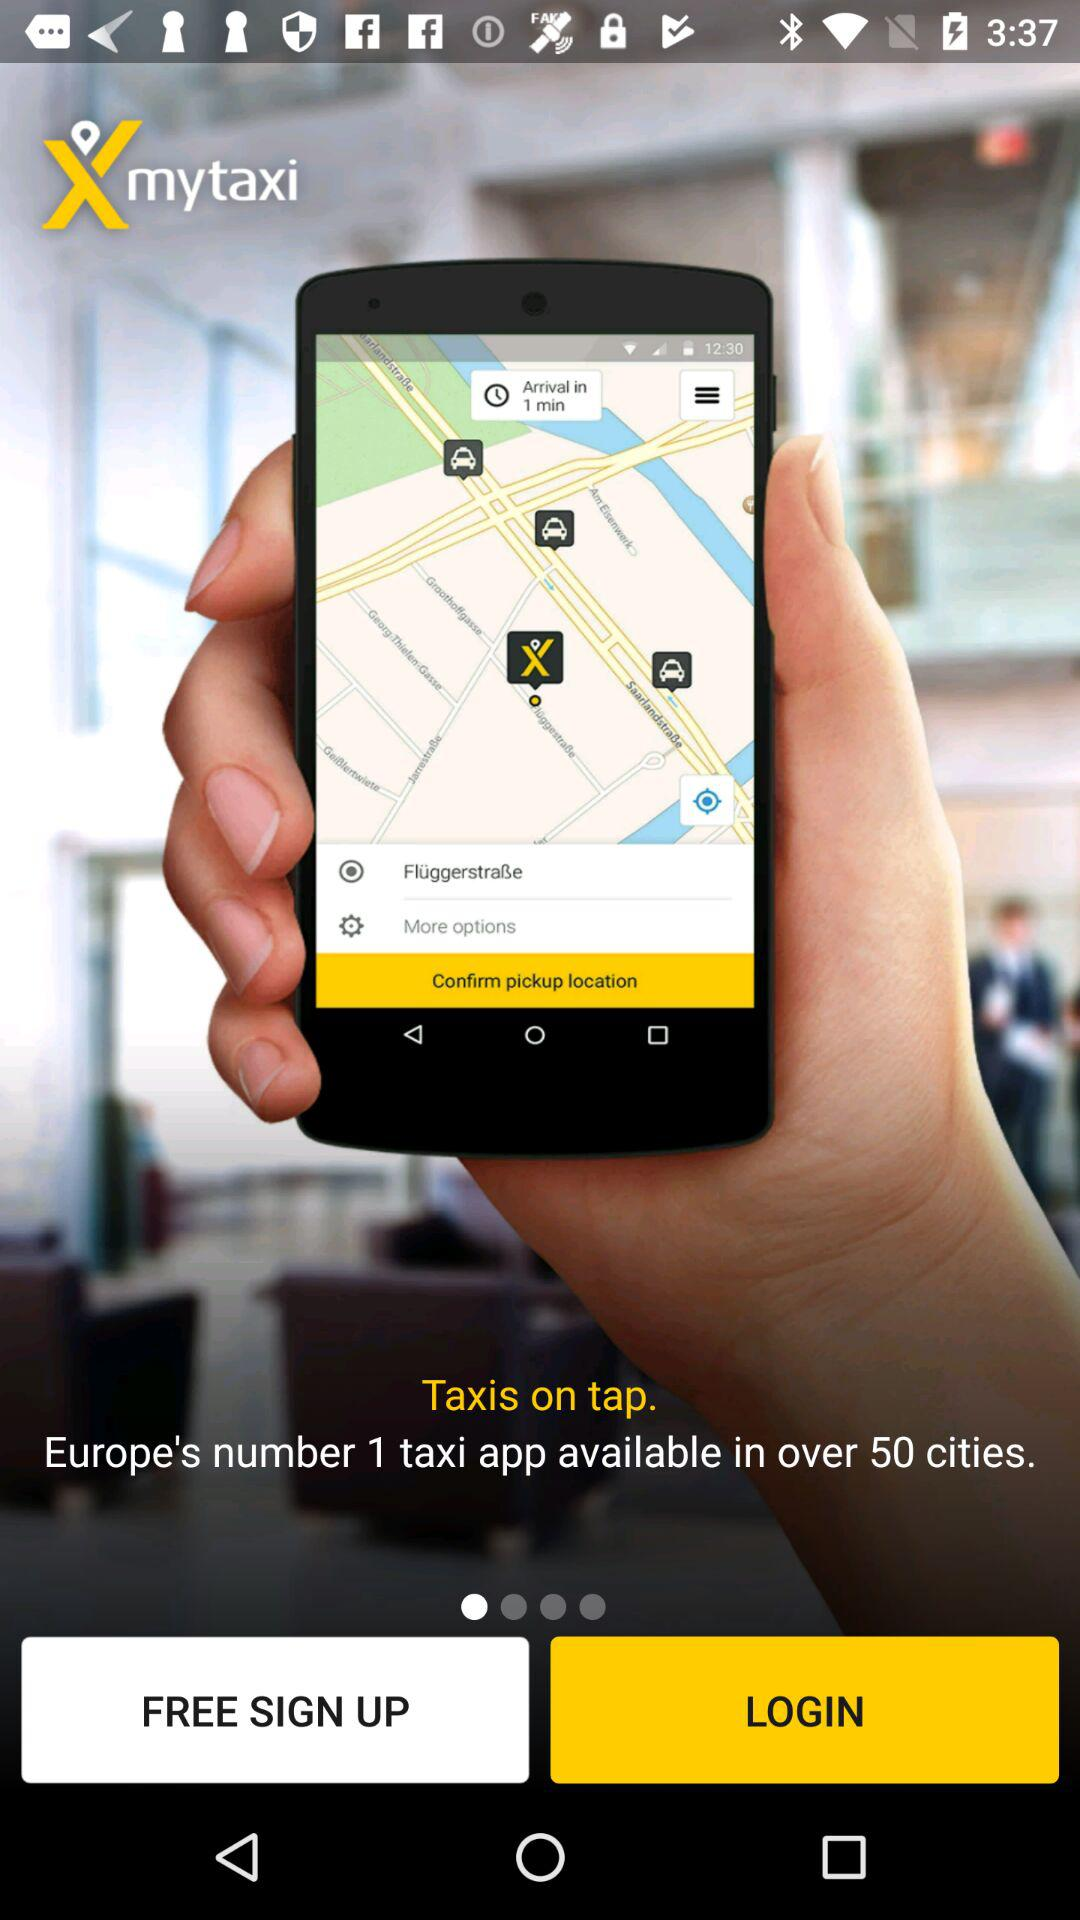What is the name of the application? The name of the application is "mytaxi". 